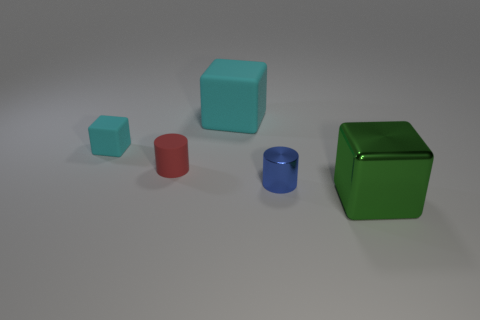Subtract all green cylinders. Subtract all red blocks. How many cylinders are left? 2 Subtract all blue cubes. How many yellow cylinders are left? 0 Subtract all small things. Subtract all red things. How many objects are left? 1 Add 3 small cyan rubber things. How many small cyan rubber things are left? 4 Add 3 small matte cylinders. How many small matte cylinders exist? 4 Add 5 tiny gray metal blocks. How many objects exist? 10 Subtract all cyan blocks. How many blocks are left? 1 Subtract all shiny cubes. How many cubes are left? 2 Subtract 0 green balls. How many objects are left? 5 Subtract all cylinders. How many objects are left? 3 